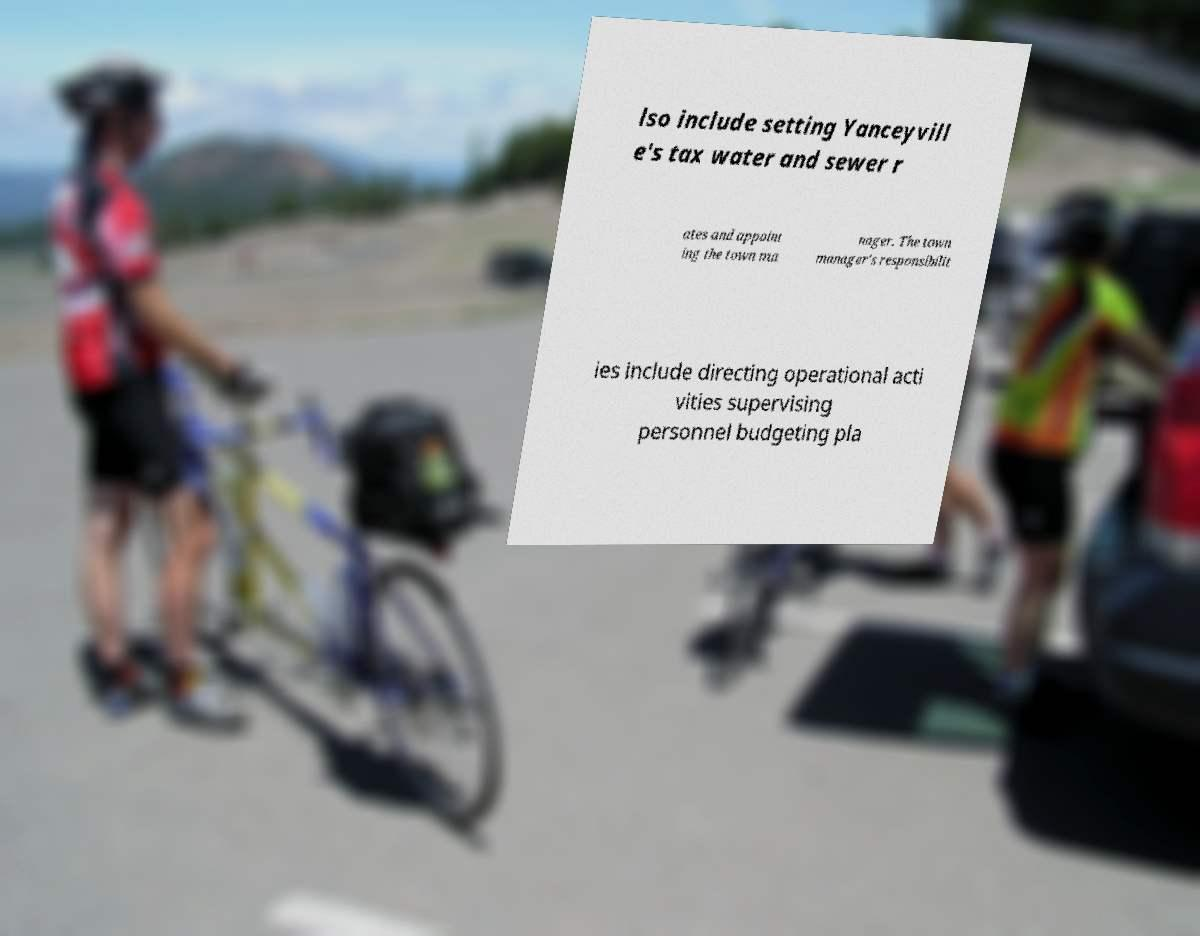What messages or text are displayed in this image? I need them in a readable, typed format. lso include setting Yanceyvill e's tax water and sewer r ates and appoint ing the town ma nager. The town manager's responsibilit ies include directing operational acti vities supervising personnel budgeting pla 